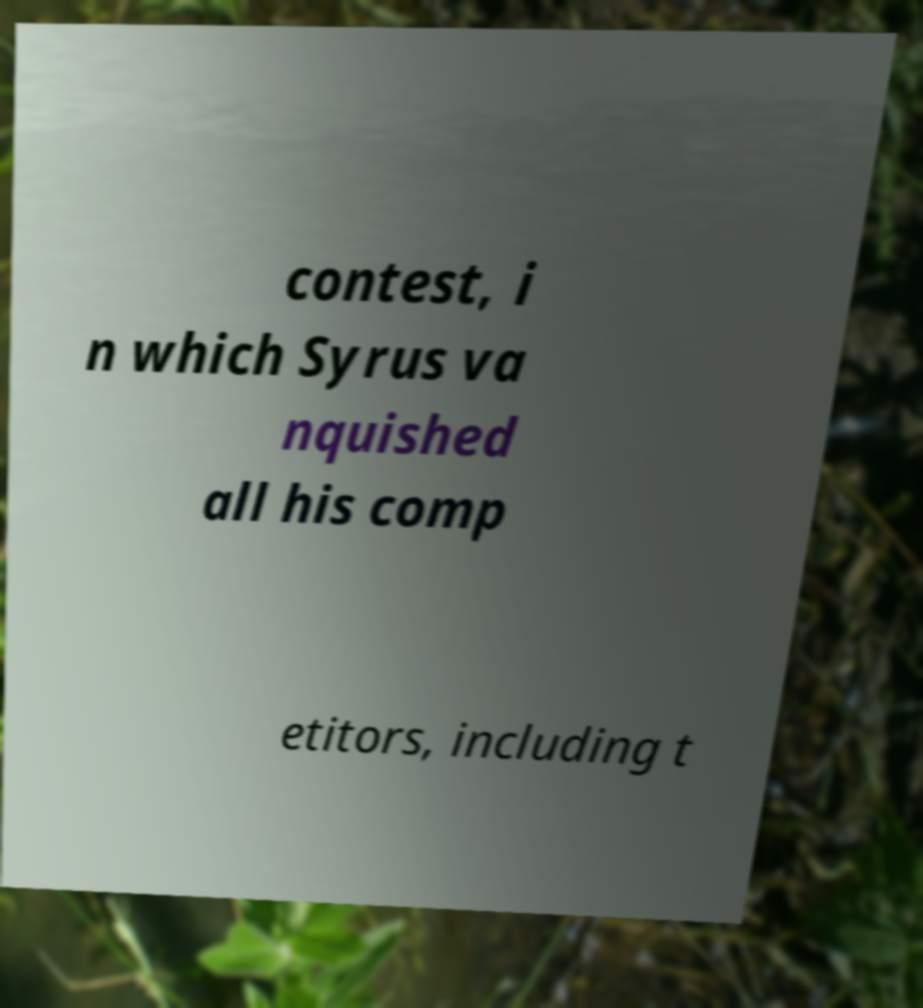Please read and relay the text visible in this image. What does it say? contest, i n which Syrus va nquished all his comp etitors, including t 